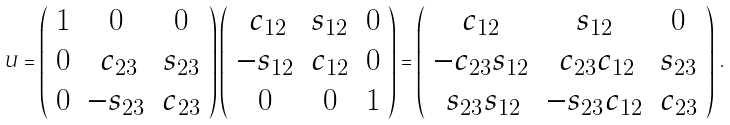Convert formula to latex. <formula><loc_0><loc_0><loc_500><loc_500>U = \left ( \begin{array} { c c c } 1 & 0 & 0 \\ 0 & \, c _ { 2 3 } & s _ { 2 3 } \\ 0 & - s _ { 2 3 } & c _ { 2 3 } \end{array} \right ) \left ( \begin{array} { c c c } \, c _ { 1 2 } & s _ { 1 2 } & 0 \\ - s _ { 1 2 } & c _ { 1 2 } & 0 \\ 0 & 0 & 1 \end{array} \right ) = \left ( \begin{array} { c c c } c _ { 1 2 } & s _ { 1 2 } & 0 \\ - c _ { 2 3 } s _ { 1 2 } & \, c _ { 2 3 } c _ { 1 2 } & s _ { 2 3 } \\ \, s _ { 2 3 } s _ { 1 2 } & - s _ { 2 3 } c _ { 1 2 } & c _ { 2 3 } \end{array} \right ) \, .</formula> 